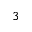<formula> <loc_0><loc_0><loc_500><loc_500>^ { 3 }</formula> 